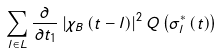Convert formula to latex. <formula><loc_0><loc_0><loc_500><loc_500>\sum _ { l \in L } \frac { \partial \, } { \partial t _ { 1 } } \left | \chi _ { B } \left ( t - l \right ) \right | ^ { 2 } Q \left ( \sigma _ { l } ^ { * } \left ( t \right ) \right )</formula> 